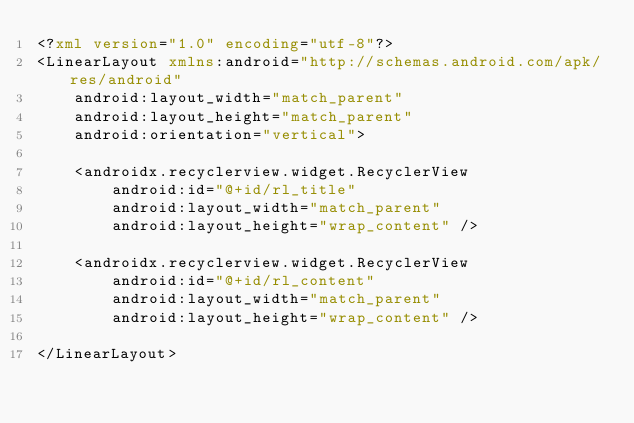<code> <loc_0><loc_0><loc_500><loc_500><_XML_><?xml version="1.0" encoding="utf-8"?>
<LinearLayout xmlns:android="http://schemas.android.com/apk/res/android"
    android:layout_width="match_parent"
    android:layout_height="match_parent"
    android:orientation="vertical">

    <androidx.recyclerview.widget.RecyclerView
        android:id="@+id/rl_title"
        android:layout_width="match_parent"
        android:layout_height="wrap_content" />

    <androidx.recyclerview.widget.RecyclerView
        android:id="@+id/rl_content"
        android:layout_width="match_parent"
        android:layout_height="wrap_content" />

</LinearLayout></code> 